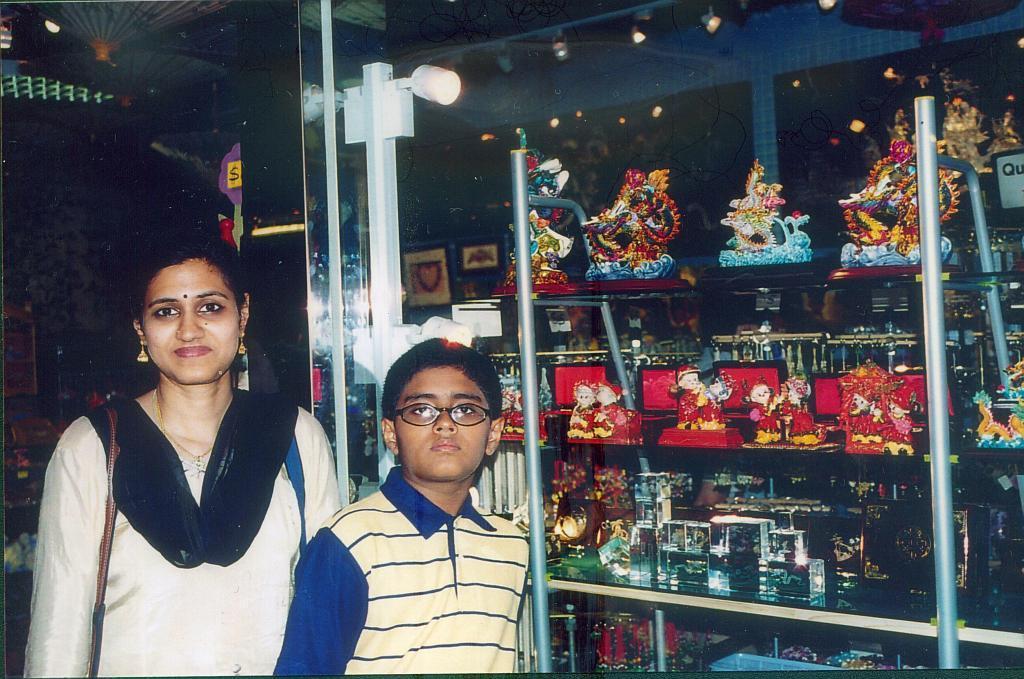Please provide a concise description of this image. In this image there is one woman and one boy standing and on the right side there is a glass box. In the box there are some statues and some toys and there is one pole and light, and in the background there is a wall and some objects. 